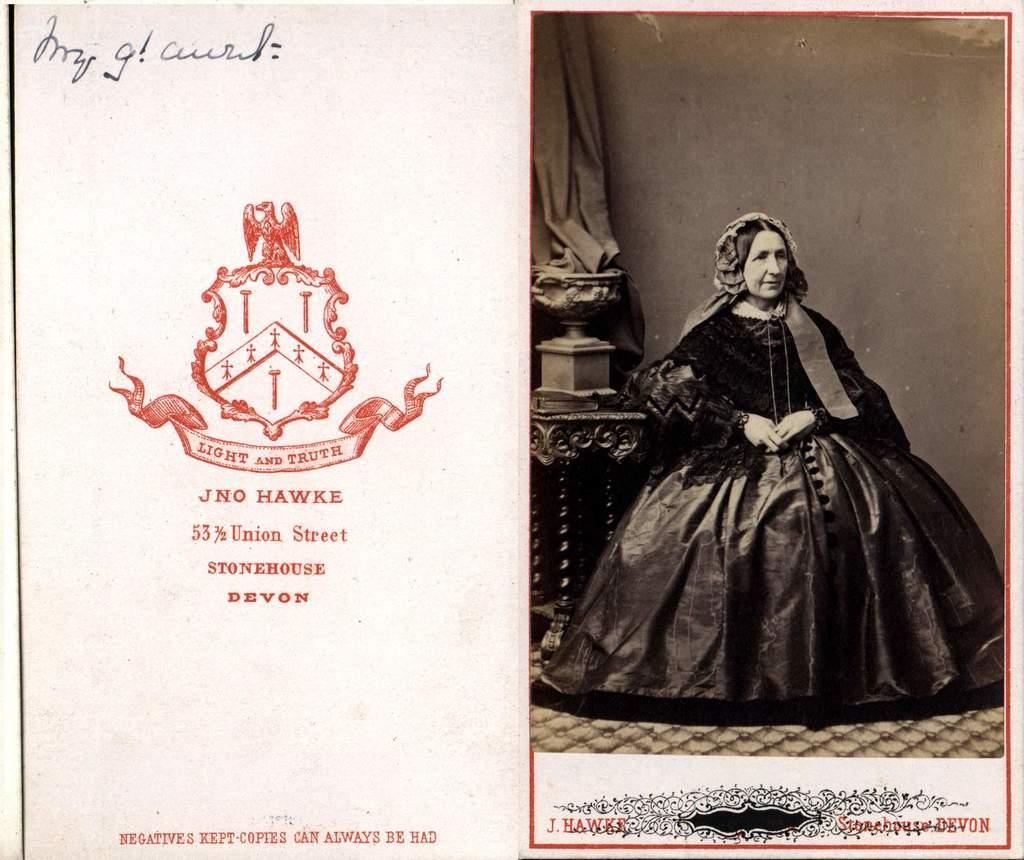What is the main subject of the image? There is a picture of a lady sitting on a chair. What other objects can be seen in the image? There is a pillar, a stamp, a signature, and notes in the image. What type of fruit is being offered to the lady in the image? There is no fruit present in the image. What attempt is being made by the lady in the image? The image does not depict any specific action or attempt being made by the lady. 